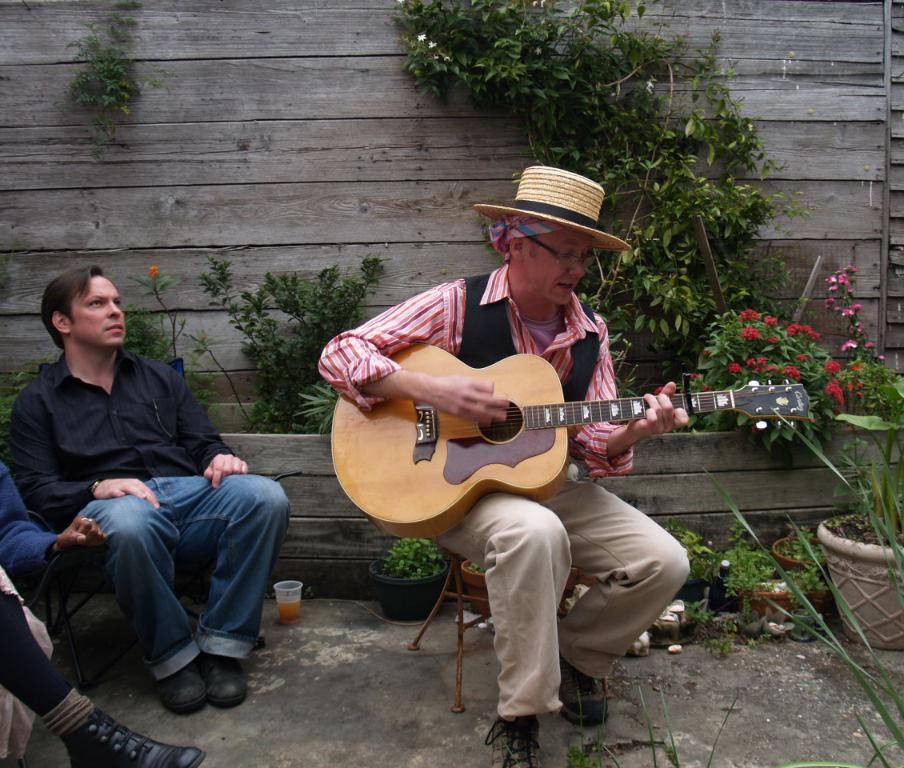What are the persons in the image doing? The persons in the image are sitting on chairs. What is one person doing while sitting on a chair? One person is playing a guitar. Can you describe the appearance of the guitar player? The guitar player is wearing a hat and glasses. What can be seen in the background of the image? There is a wooden wall, plants, flowers, and a pot in the background. What type of silk is being used to make the guitar strings in the image? There is no silk mentioned or visible in the image; the guitar strings are not described. What hobbies do the persons in the image have, besides playing the guitar? The provided facts do not mention any other hobbies of the persons in the image. Is there a tiger present in the image? No, there is no tiger visible in the image. 